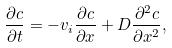Convert formula to latex. <formula><loc_0><loc_0><loc_500><loc_500>\frac { \partial c } { \partial t } = - v _ { i } \frac { \partial c } { \partial x } + D \frac { \partial ^ { 2 } c } { \partial x ^ { 2 } } ,</formula> 